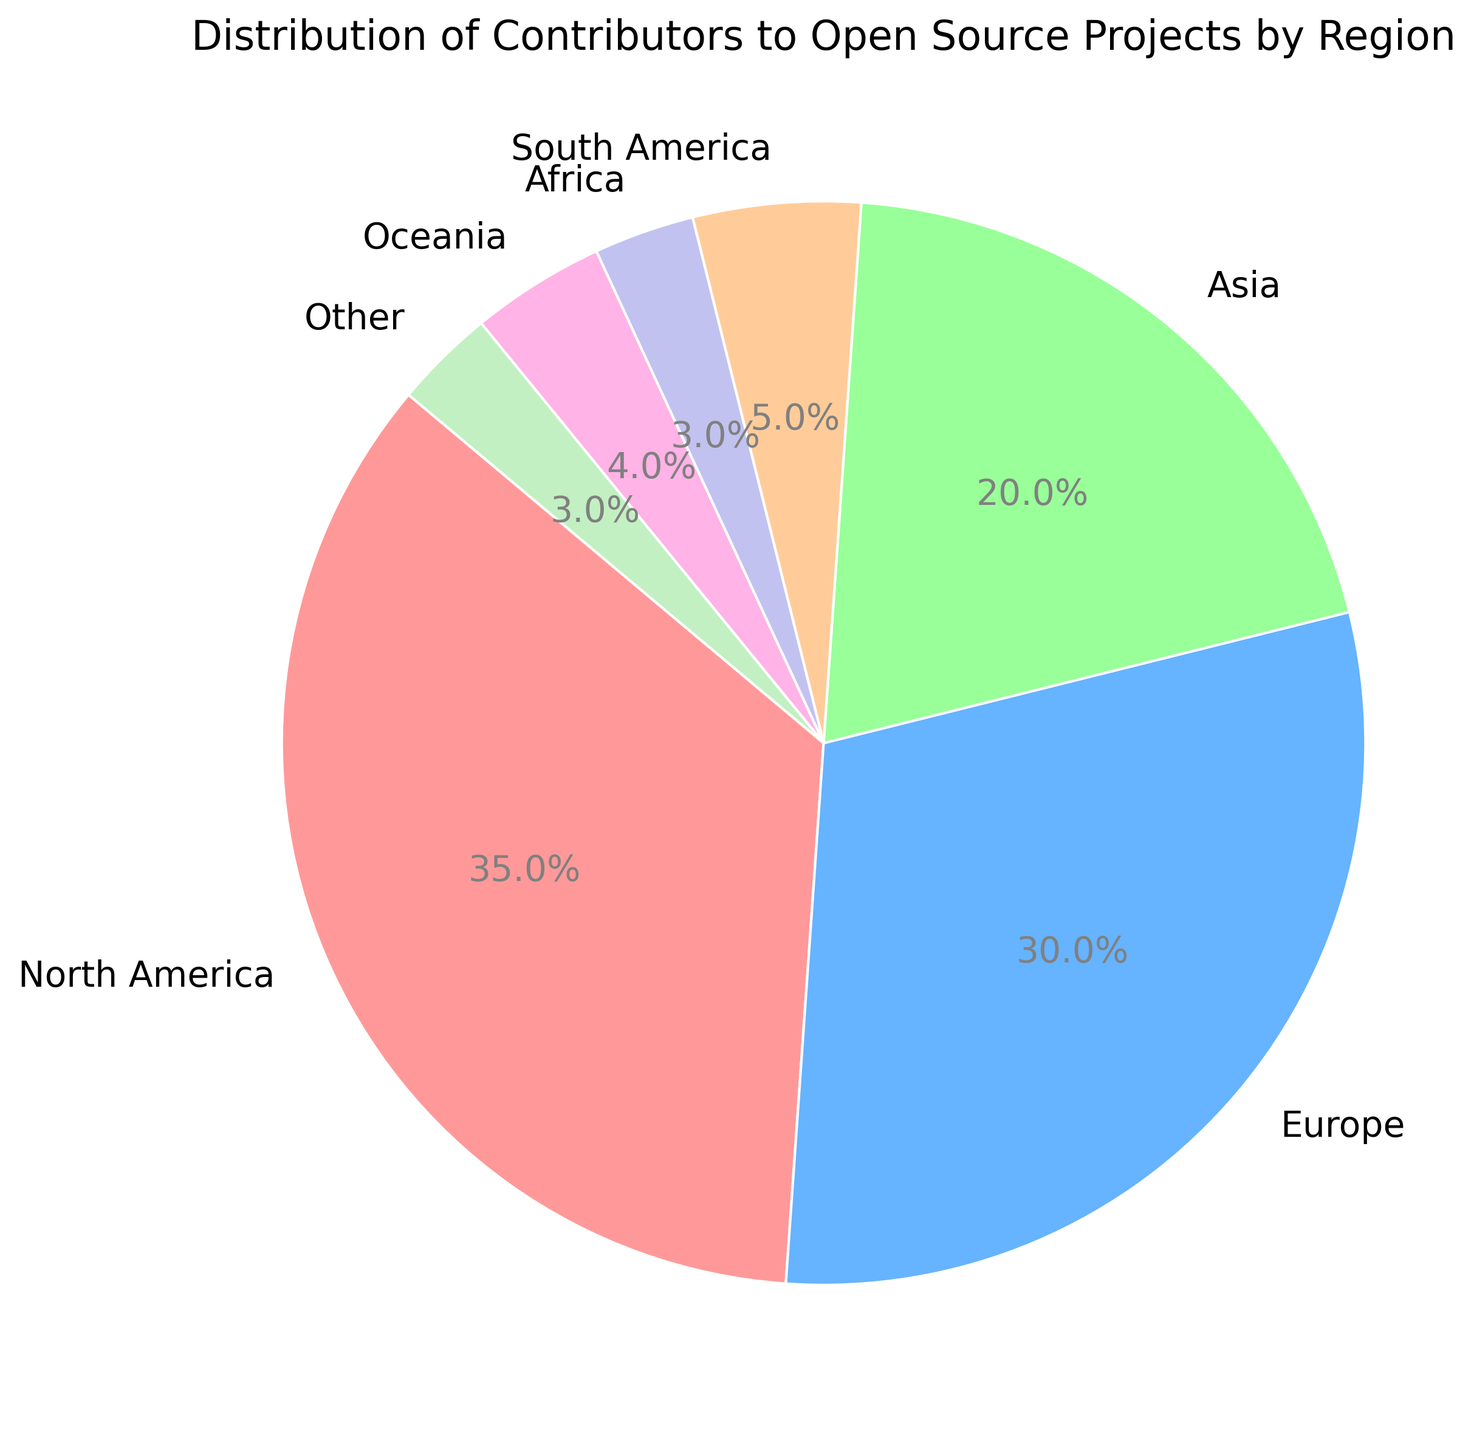What's the highest percentage represented in the pie chart? The region with the largest slice in the pie chart is North America, which has the highest percentage.
Answer: 35% What is the combined percentage of contributors from Asia and Europe? Add the percentage of contributors from Asia (20%) and Europe (30%). 20% + 30% = 50%
Answer: 50% Which regions have the same percentage of contributors? From the pie chart, Africa and "Other" both contribute 3% each.
Answer: Africa and Other How does the percentage of contributors from South America compare to Oceania? The percentage of contributors from South America is 5%, while Oceania is 4%. South America is 1% higher than Oceania.
Answer: South America is higher by 1% What is the total percentage of contributors from the combined regions of North America, Europe, and Asia? Sum the percentages of North America (35%), Europe (30%), and Asia (20%). 35% + 30% + 20% = 85%
Answer: 85% Which region has the smallest percentage of contributors? The smallest slice on the pie chart represents Africa, with 3%.
Answer: Africa By how many percentage points does the contribution of Europe exceed that of Oceania? The percentage of contributors from Europe is 30%, while Oceania is 4%. The difference is 30% - 4% = 26%.
Answer: 26% What is the average percentage of contributors from South America, Africa, and Oceania? Add the percentages of South America (5%), Africa (3%), and Oceania (4%) and divide by 3. (5% + 3% + 4%) / 3 = 12% / 3 = 4%.
Answer: 4% Which regions collectively make up less than 15% of the contributors? The combined percentage of South America (5%), Africa (3%), Oceania (4%), and "Other" (3%) is 5% + 3% + 4% + 3% = 15%. Adjust the calculation to include only those regions whose total is less than 15%.
Answer: Africa, Oceania, and Other have a combined percentage of 10% What is the contribution percentage difference between North America and Asia? Subtract the percentage of contributors from Asia (20%) from North America (35%). 35% - 20% = 15%
Answer: 15% 